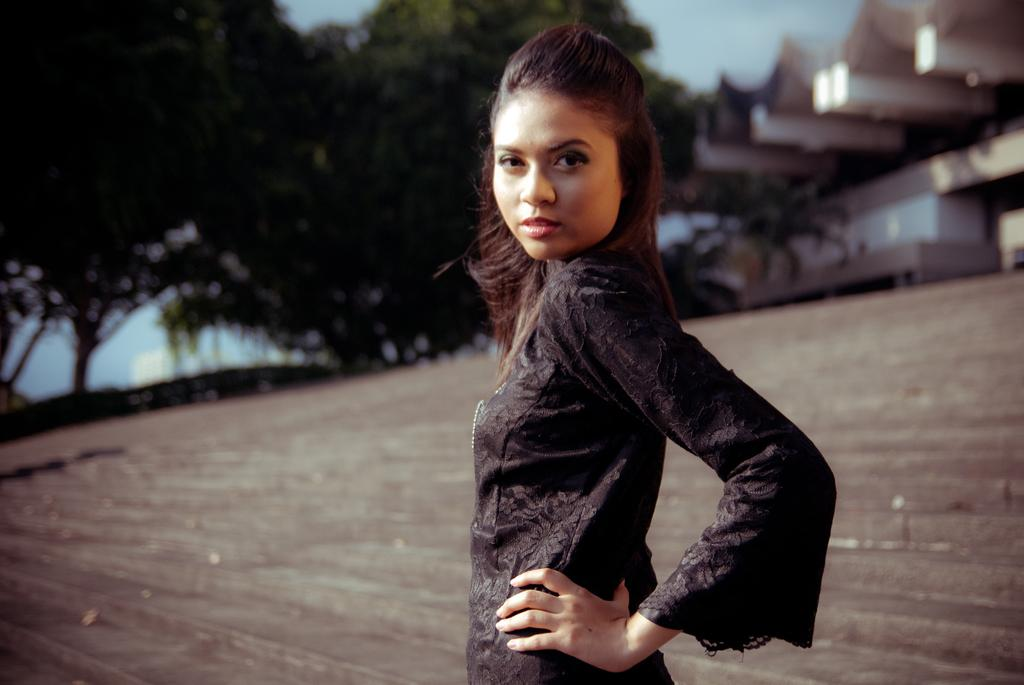Who is the main subject in the image? There is a lady in the center of the image. What is the lady's position in the image? The lady is on the ground. What can be seen in the background of the image? There are trees and buildings in the background of the image. How many spiders are crawling on the lady in the image? There are no spiders visible in the image; the lady is on the ground with no spiders present. 